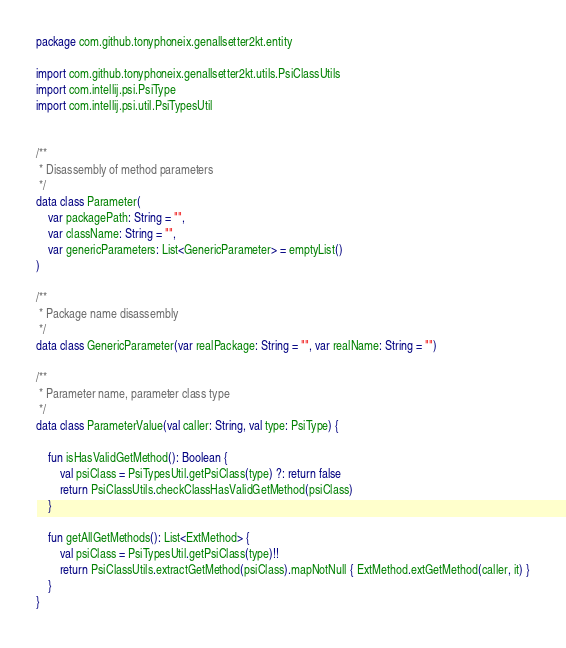<code> <loc_0><loc_0><loc_500><loc_500><_Kotlin_>package com.github.tonyphoneix.genallsetter2kt.entity

import com.github.tonyphoneix.genallsetter2kt.utils.PsiClassUtils
import com.intellij.psi.PsiType
import com.intellij.psi.util.PsiTypesUtil


/**
 * Disassembly of method parameters
 */
data class Parameter(
    var packagePath: String = "",
    var className: String = "",
    var genericParameters: List<GenericParameter> = emptyList()
)

/**
 * Package name disassembly
 */
data class GenericParameter(var realPackage: String = "", var realName: String = "")

/**
 * Parameter name, parameter class type
 */
data class ParameterValue(val caller: String, val type: PsiType) {

    fun isHasValidGetMethod(): Boolean {
        val psiClass = PsiTypesUtil.getPsiClass(type) ?: return false
        return PsiClassUtils.checkClassHasValidGetMethod(psiClass)
    }

    fun getAllGetMethods(): List<ExtMethod> {
        val psiClass = PsiTypesUtil.getPsiClass(type)!!
        return PsiClassUtils.extractGetMethod(psiClass).mapNotNull { ExtMethod.extGetMethod(caller, it) }
    }
}</code> 